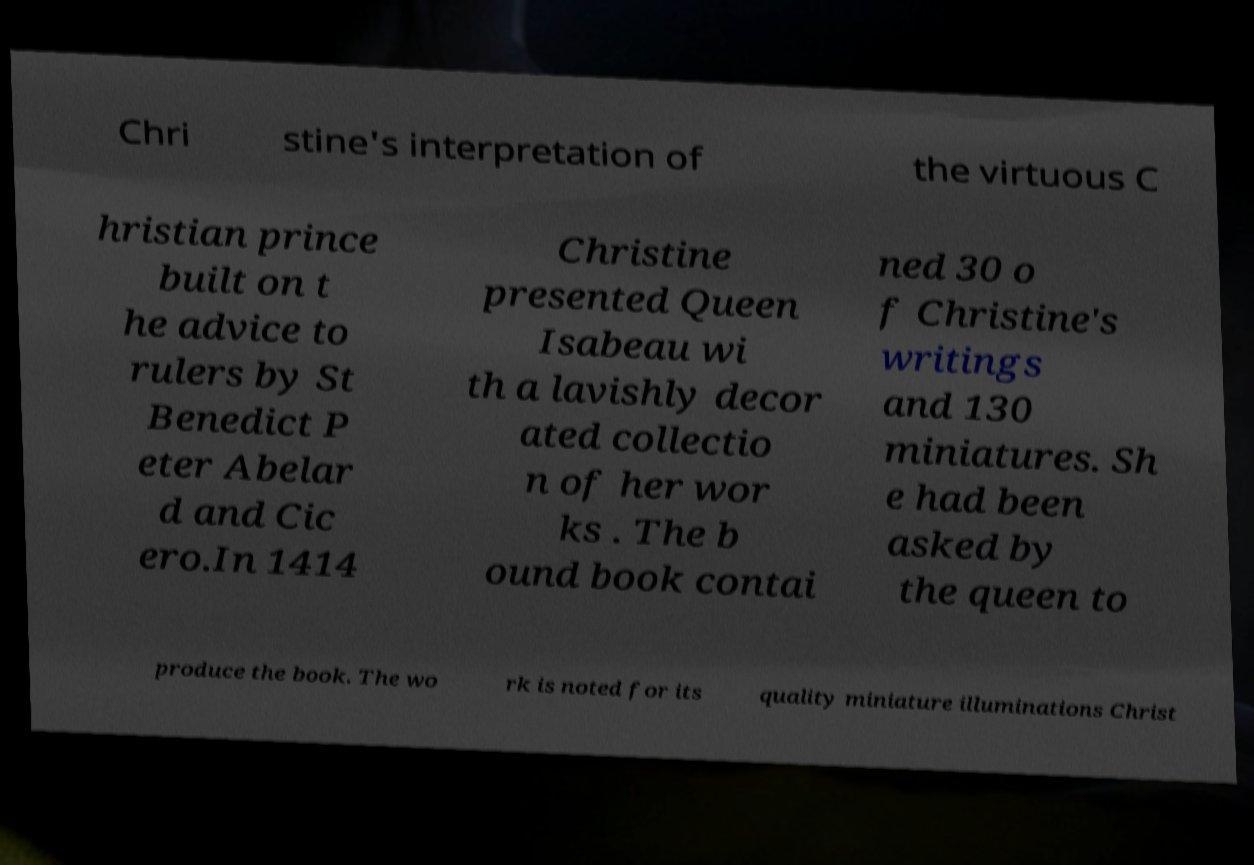For documentation purposes, I need the text within this image transcribed. Could you provide that? Chri stine's interpretation of the virtuous C hristian prince built on t he advice to rulers by St Benedict P eter Abelar d and Cic ero.In 1414 Christine presented Queen Isabeau wi th a lavishly decor ated collectio n of her wor ks . The b ound book contai ned 30 o f Christine's writings and 130 miniatures. Sh e had been asked by the queen to produce the book. The wo rk is noted for its quality miniature illuminations Christ 